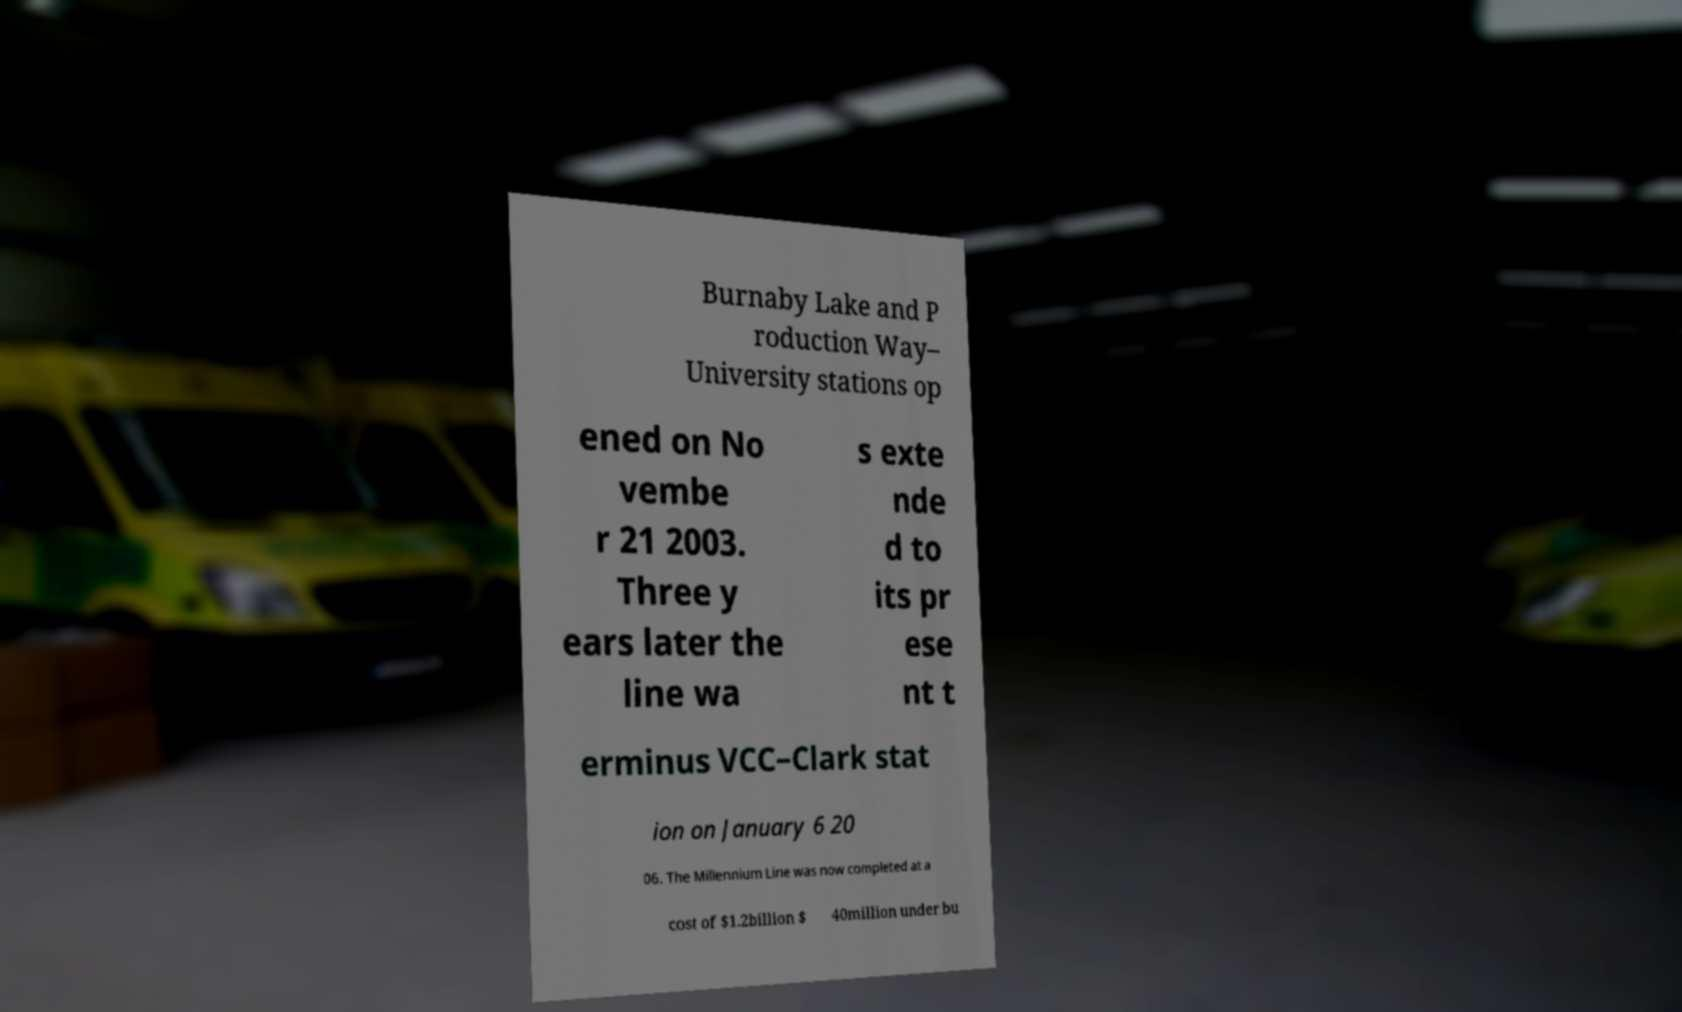Please read and relay the text visible in this image. What does it say? Burnaby Lake and P roduction Way– University stations op ened on No vembe r 21 2003. Three y ears later the line wa s exte nde d to its pr ese nt t erminus VCC–Clark stat ion on January 6 20 06. The Millennium Line was now completed at a cost of $1.2billion $ 40million under bu 